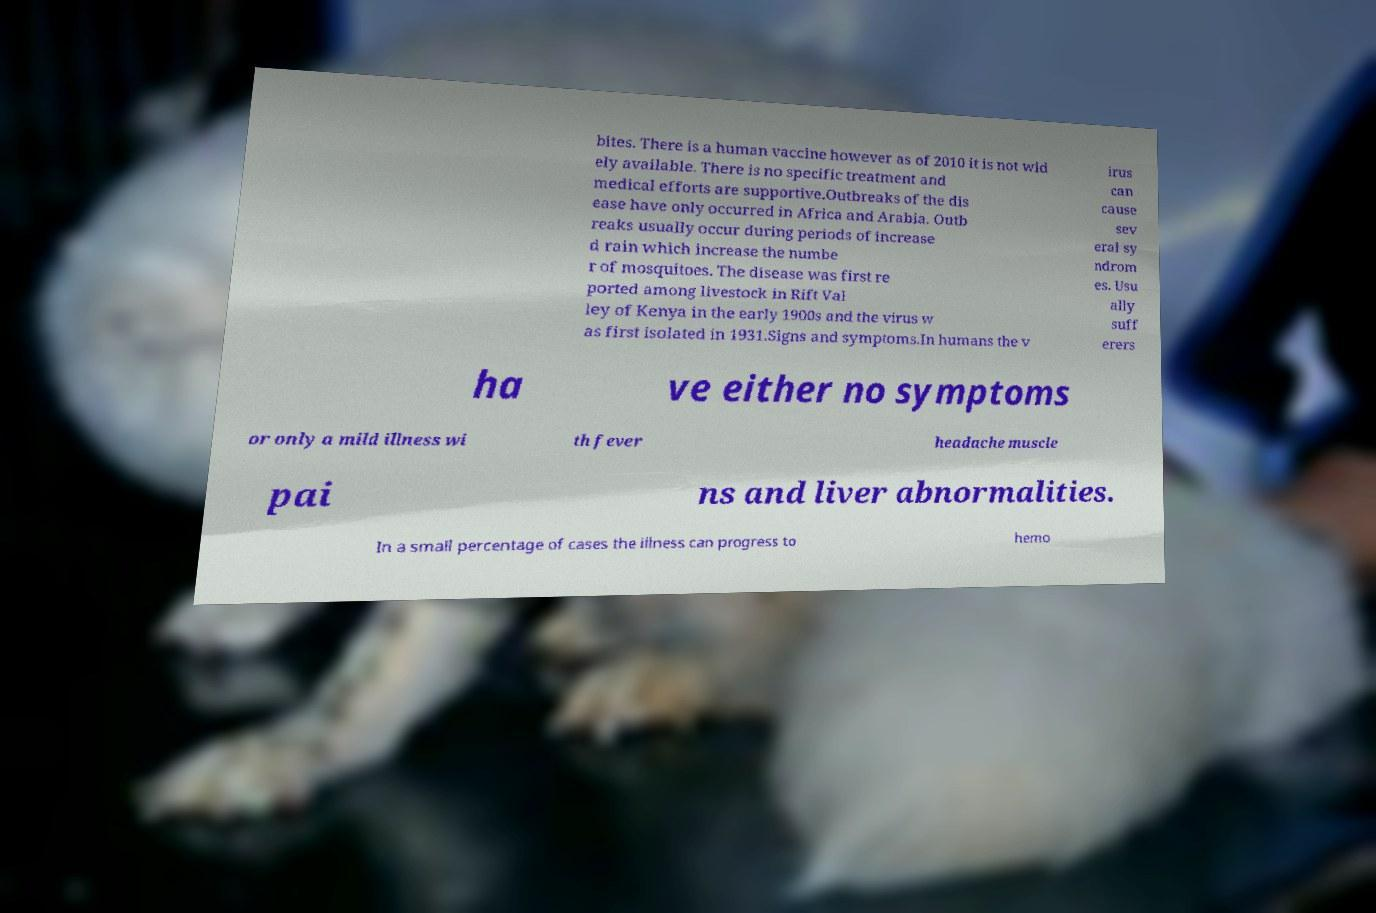Please identify and transcribe the text found in this image. bites. There is a human vaccine however as of 2010 it is not wid ely available. There is no specific treatment and medical efforts are supportive.Outbreaks of the dis ease have only occurred in Africa and Arabia. Outb reaks usually occur during periods of increase d rain which increase the numbe r of mosquitoes. The disease was first re ported among livestock in Rift Val ley of Kenya in the early 1900s and the virus w as first isolated in 1931.Signs and symptoms.In humans the v irus can cause sev eral sy ndrom es. Usu ally suff erers ha ve either no symptoms or only a mild illness wi th fever headache muscle pai ns and liver abnormalities. In a small percentage of cases the illness can progress to hemo 